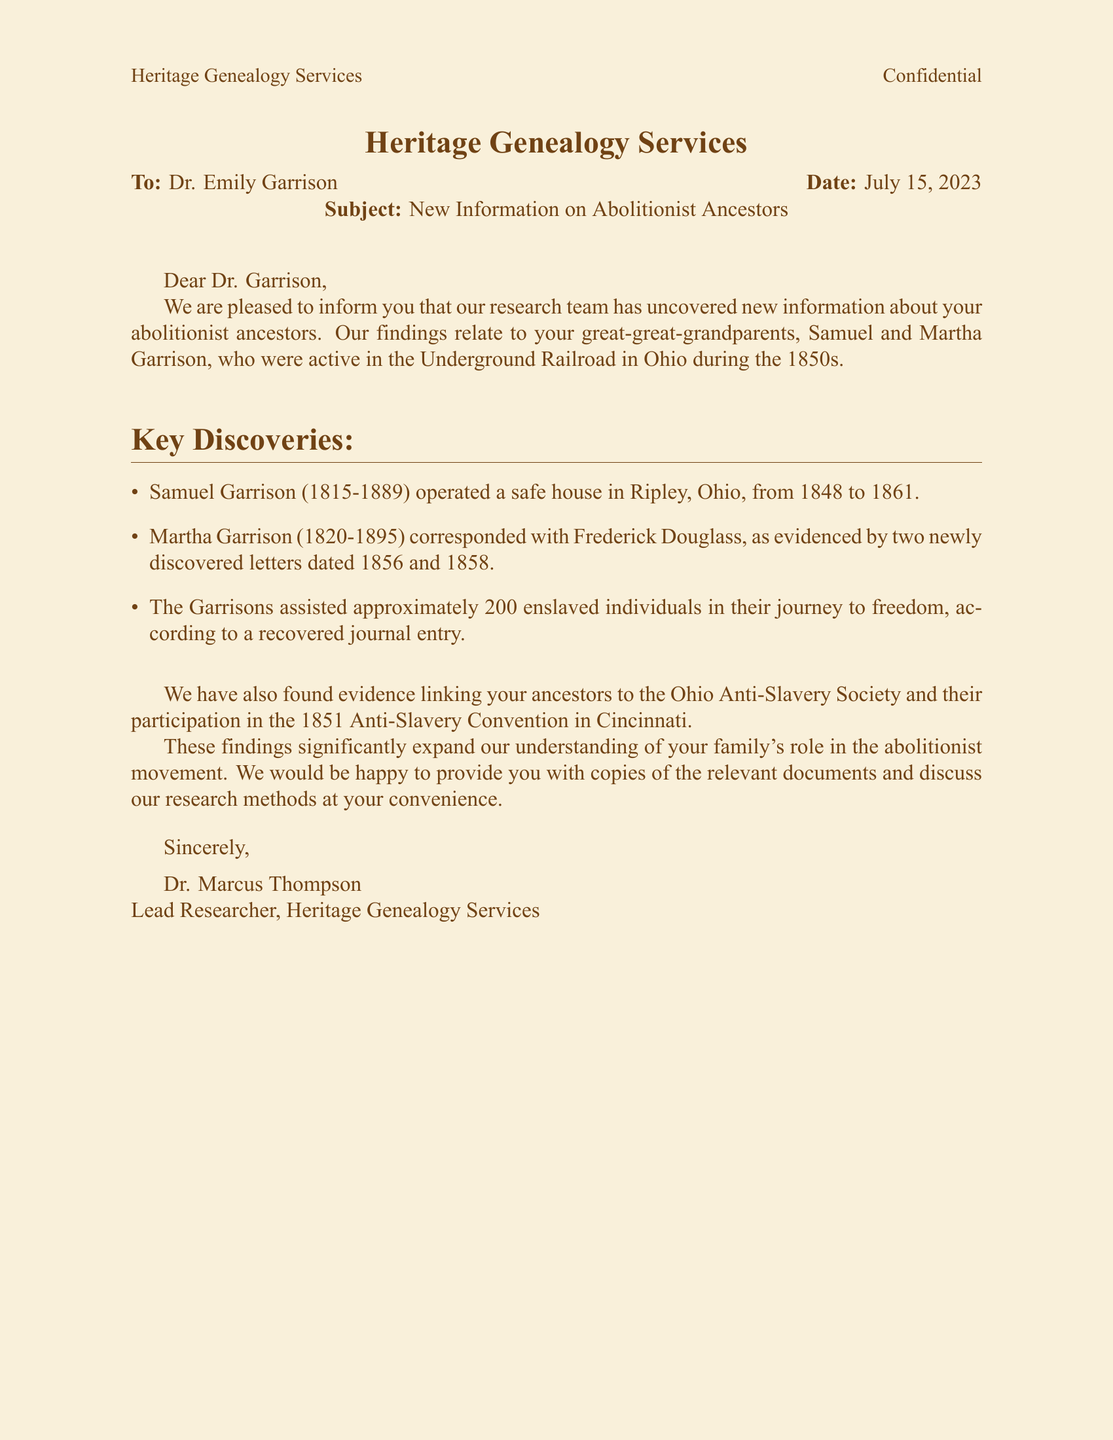What are the names of the ancestors mentioned? The names of the ancestors are Samuel and Martha Garrison, as stated in the letter.
Answer: Samuel and Martha Garrison In which state did the Garrison family operate a safe house? The letter specifies that the Garrison family operated a safe house in Ripley, Ohio.
Answer: Ohio How many enslaved individuals did the Garrisons assist? According to the recovered journal entry mentioned, the Garrisons assisted approximately 200 enslaved individuals.
Answer: 200 What years did Samuel Garrison operate his safe house? The document states that Samuel Garrison operated a safe house from 1848 to 1861.
Answer: 1848 to 1861 Who did Martha Garrison correspond with? The letter indicates that Martha Garrison corresponded with Frederick Douglass, as evidenced by the newly discovered letters.
Answer: Frederick Douglass What type of society were the Garnsons linked to? The document mentions evidence linking the Garrisons to the Ohio Anti-Slavery Society.
Answer: Ohio Anti-Slavery Society What was the date of the letter? The fax states the date of communication as July 15, 2023.
Answer: July 15, 2023 Who is the lead researcher mentioned in the fax? The lead researcher, as signed at the end of the document, is Dr. Marcus Thompson.
Answer: Dr. Marcus Thompson What type of document is this communication? The document is categorized as a fax communication from a genealogy research service.
Answer: Fax 